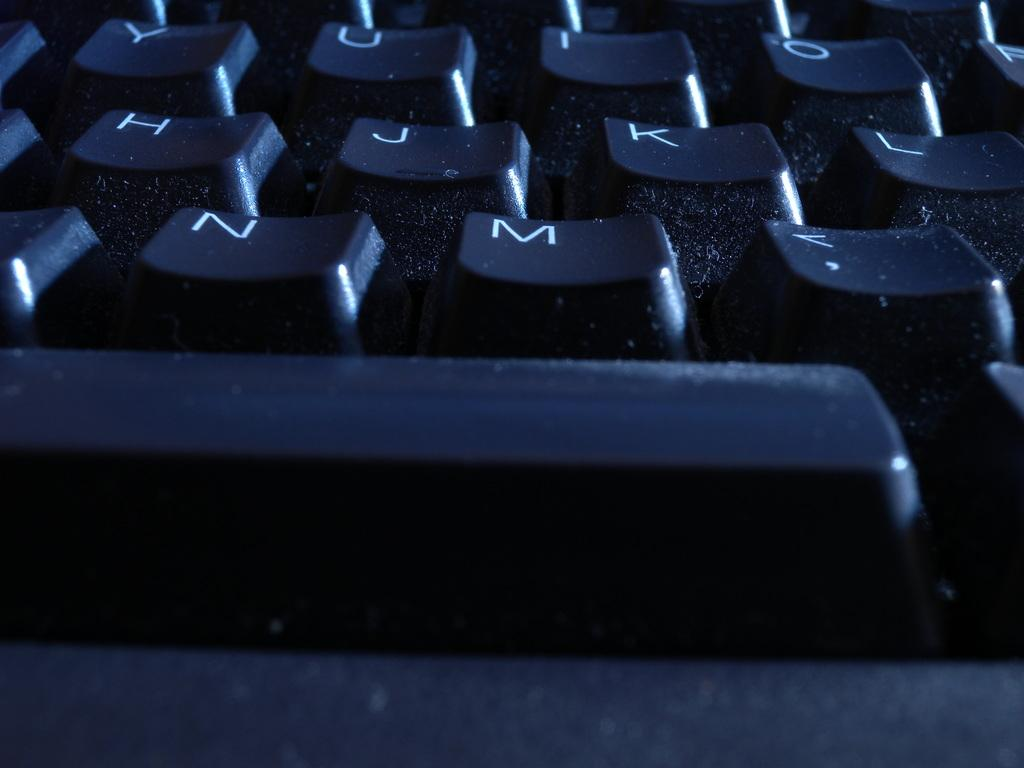What type of object is shown in the image? Keyboard keys are visible in the image. Can you describe the appearance of the keyboard keys? The keyboard keys are small, rectangular buttons with letters, numbers, or symbols printed on them. What might the keyboard keys be used for? The keyboard keys are likely used for typing on a computer or other electronic device. How many boats can be seen sailing in the image? There are no boats present in the image; it only shows keyboard keys. What type of vegetable is growing next to the keyboard keys in the image? There are no vegetables present in the image; it only shows keyboard keys. 